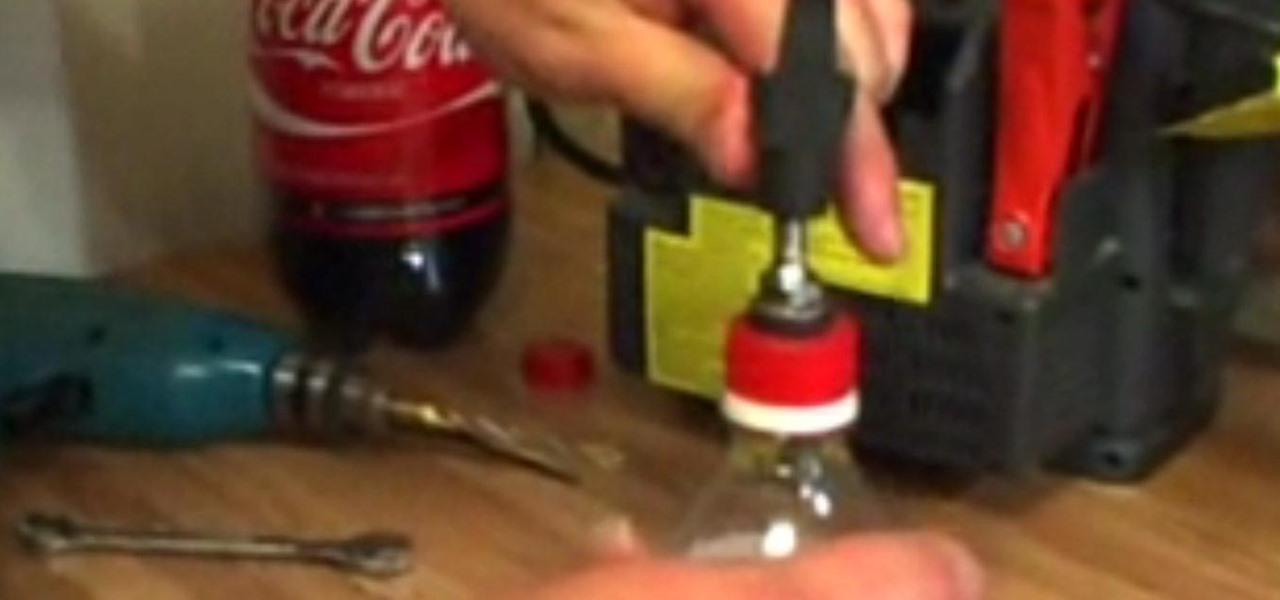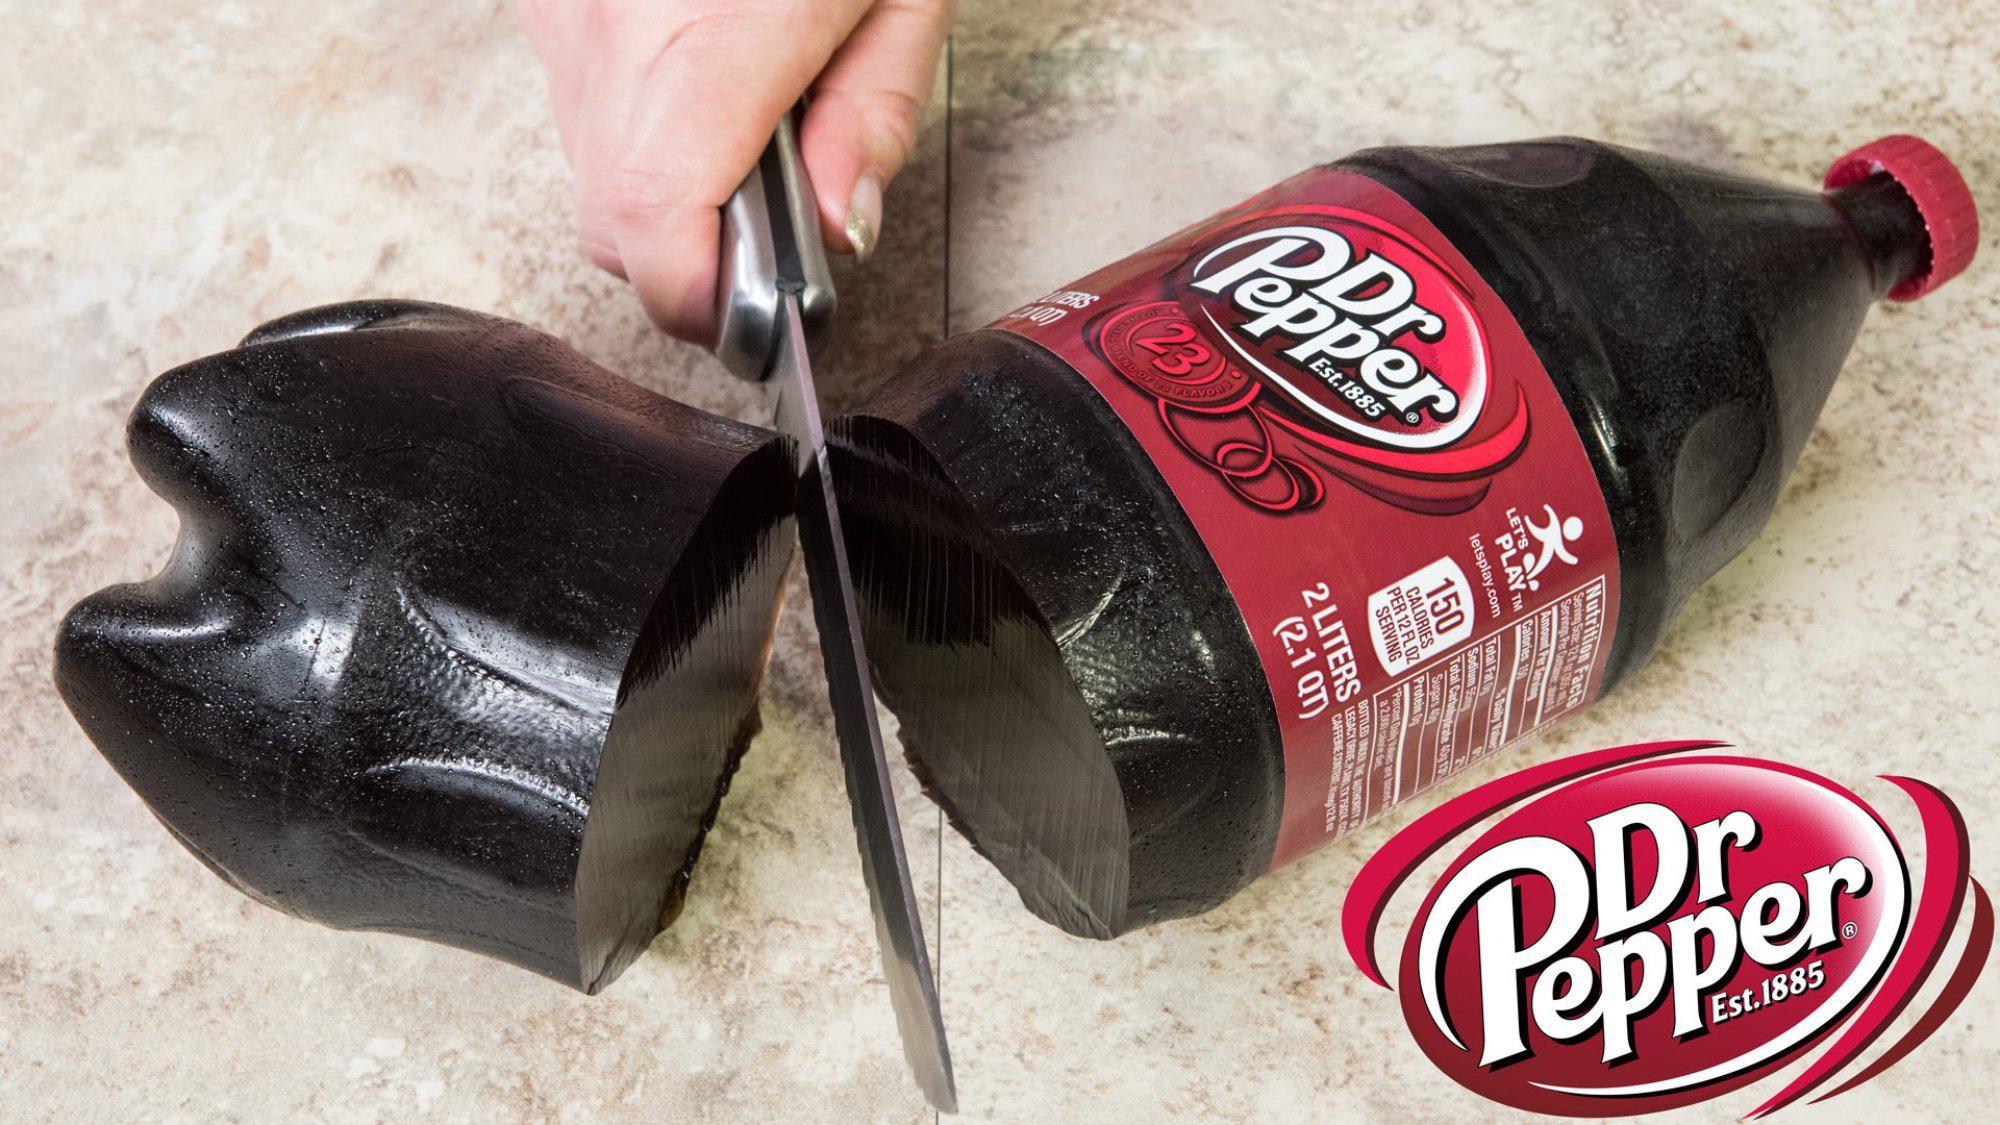The first image is the image on the left, the second image is the image on the right. Given the left and right images, does the statement "The right image shows a knife slicing through a bottle on its side, and the left image includes an upright bottle of cola." hold true? Answer yes or no. Yes. The first image is the image on the left, the second image is the image on the right. Assess this claim about the two images: "A person is holding a knife to a bottle in the image on the right.". Correct or not? Answer yes or no. Yes. 